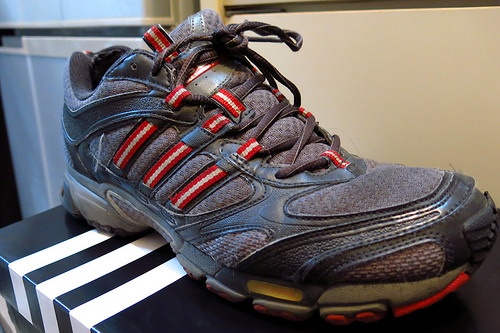<image>
Is there a shoe in front of the cabinet? Yes. The shoe is positioned in front of the cabinet, appearing closer to the camera viewpoint. 